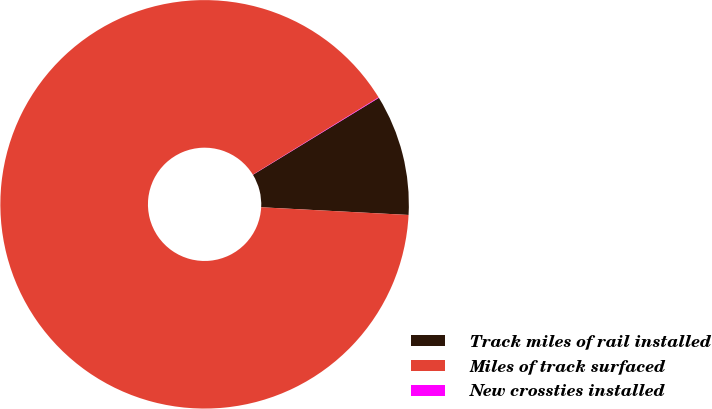Convert chart to OTSL. <chart><loc_0><loc_0><loc_500><loc_500><pie_chart><fcel>Track miles of rail installed<fcel>Miles of track surfaced<fcel>New crossties installed<nl><fcel>9.56%<fcel>90.4%<fcel>0.04%<nl></chart> 